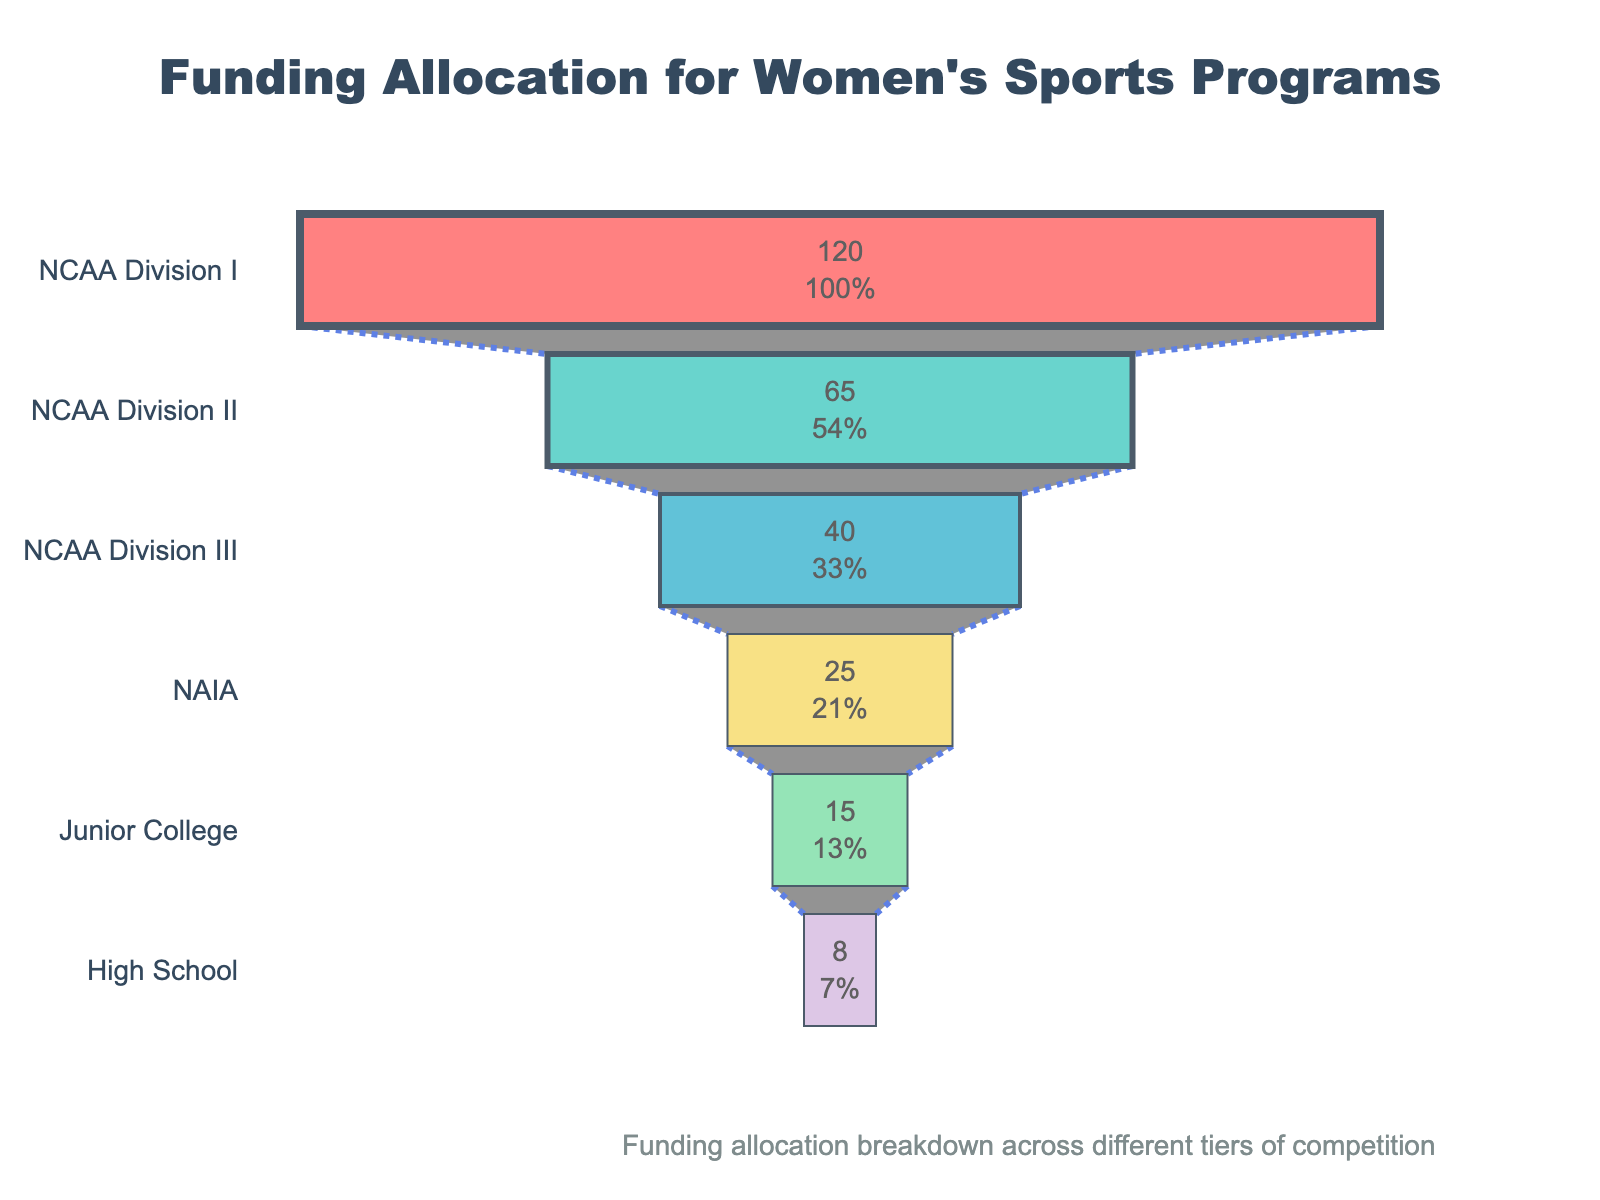what's the title of the funnel chart? The title of the funnel chart is usually located at the top center of the figure and should be in a larger, bold font for emphasis. In this case, the title indicates the subject of the funnel chart, which is "Funding Allocation for Women's Sports Programs".
Answer: Funding Allocation for Women's Sports Programs how much funding is allocated to NCAA Division I? The funnel chart uses horizontal bars to represent the amount of funding allocated to each competition tier. The topmost bar often represents the highest value, and the funding allocation is usually written inside the bar. For NCAA Division I, the amount is shown as $120 million.
Answer: $120 million what percentage of the total funding does NCAA Division III receive from the initial total? To find the percentage of the initial total funding that NCAA Division III receives, divide NCAA Division III's allocation (40 million) by the initial funding total (sum of all allocations) and then multiply by 100. The initial total funding is $273 million (120+65+40+25+15+8). So, (40/273) * 100 ≈ 14.65%.
Answer: Approximately 14.65% compare the funding allocation between Junior College and High School To compare the funding allocations, look at the values within the respective funnel segments. Junior College has $15 million allocated whereas High School has $8 million. Junior College receives more funding compared to High School.
Answer: Junior College has more funding which competition tier has the smallest funding allocation? The smallest funding allocation is represented by the shortest bar at the bottom of the funnel, marked with the value inside the bar. For this chart, High School has the smallest allocation of $8 million.
Answer: High School what is the combined funding allocation for NCAA Division I and NCAA Division II? Add the funding allocations for NCAA Division I and NCAA Division II to get the combined allocation. NCAA Division I receives $120 million and NCAA Division II gets $65 million. So, 120 + 65 = 185 million.
Answer: $185 million how does the funding for NAIA compare to that for Junior College? Compare the funding values written within the funnel segments for NAIA and Junior College. NAIA receives $25 million whereas Junior College receives $15 million. NAIA has a higher funding allocation than Junior College.
Answer: NAIA has higher funding what percentage of the initial funding total is allocated to NAIA? To find this percentage, divide NAIA's allocation ($25 million) by the initial total funding ($273 million) and then multiply by 100. So, (25/273) * 100 ≈ 9.16%.
Answer: Approximately 9.16% how many competition tiers are represented in the funnel chart? Count the number of distinct bars or segments in the funnel chart, each representing a different competition tier. There are six tiers shown: NCAA Division I, NCAA Division II, NCAA Division III, NAIA, Junior College, and High School.
Answer: 6 what is the difference in funding allocation between the highest and the lowest tier? Subtract the funding allocation for the lowest tier (High School, $8 million) from the highest tier (NCAA Division I, $120 million). So, 120 - 8 = 112 million.
Answer: $112 million 